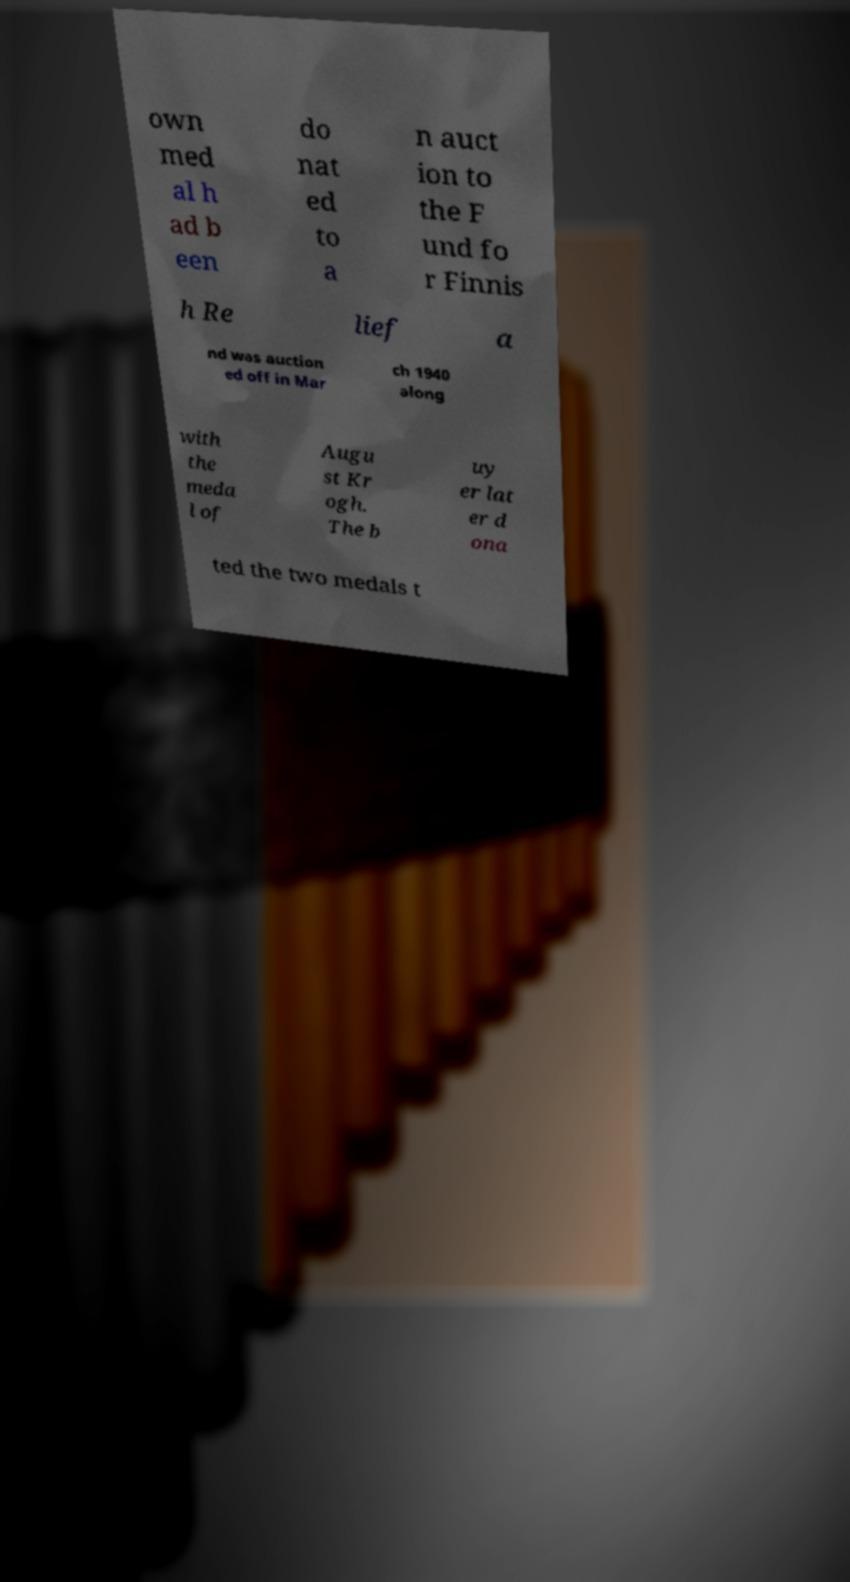Please read and relay the text visible in this image. What does it say? own med al h ad b een do nat ed to a n auct ion to the F und fo r Finnis h Re lief a nd was auction ed off in Mar ch 1940 along with the meda l of Augu st Kr ogh. The b uy er lat er d ona ted the two medals t 